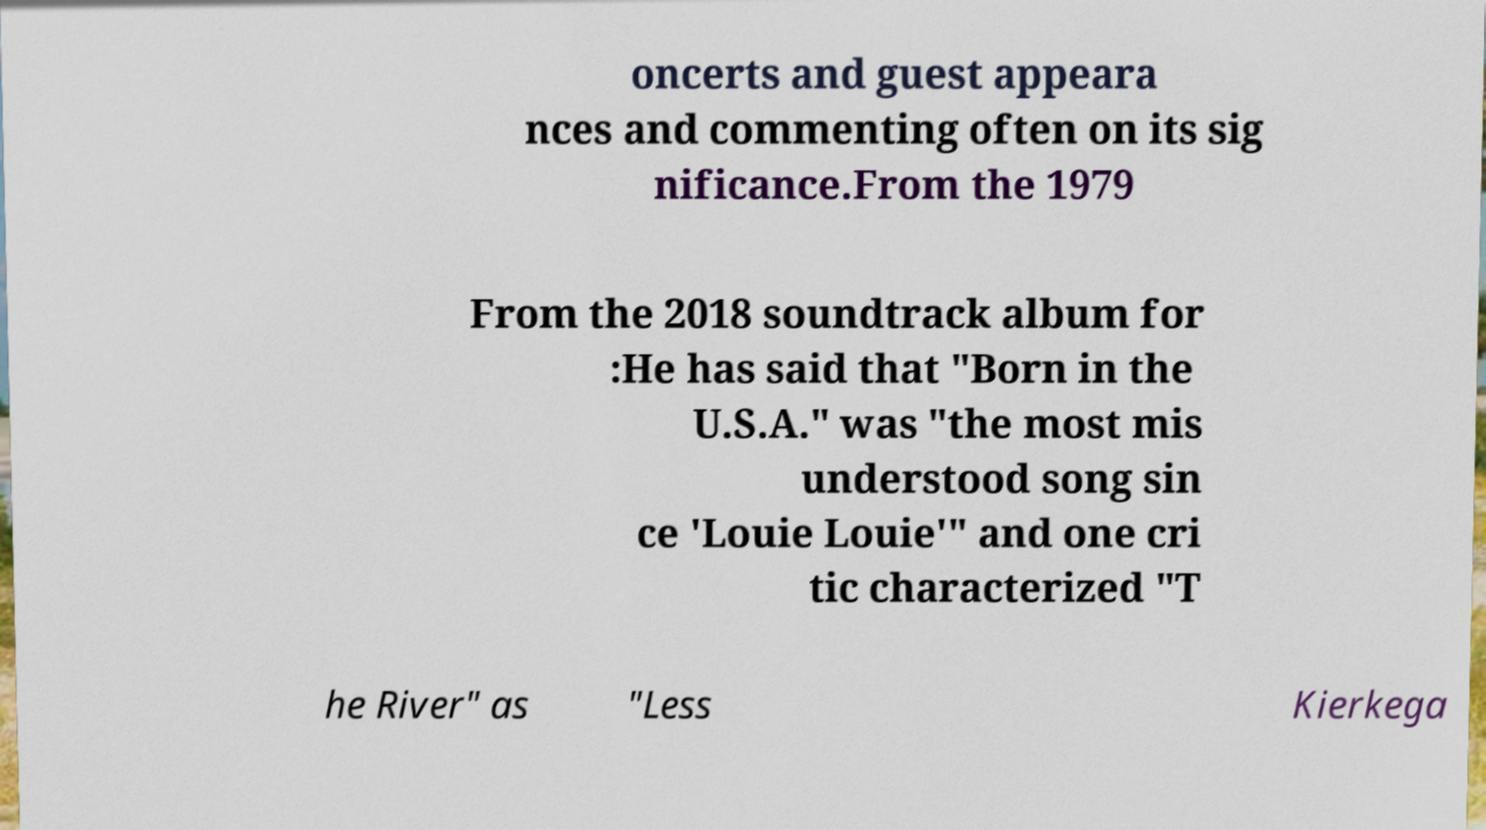I need the written content from this picture converted into text. Can you do that? oncerts and guest appeara nces and commenting often on its sig nificance.From the 1979 From the 2018 soundtrack album for :He has said that "Born in the U.S.A." was "the most mis understood song sin ce 'Louie Louie'" and one cri tic characterized "T he River" as "Less Kierkega 